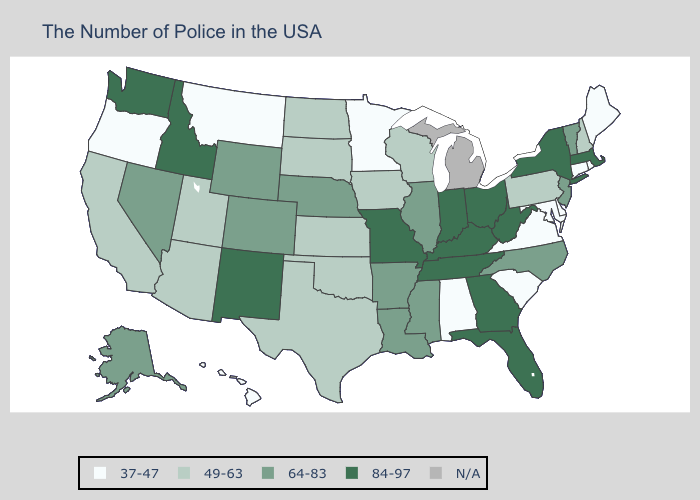Which states have the lowest value in the USA?
Keep it brief. Maine, Rhode Island, Connecticut, Delaware, Maryland, Virginia, South Carolina, Alabama, Minnesota, Montana, Oregon, Hawaii. Does Illinois have the lowest value in the USA?
Keep it brief. No. What is the lowest value in the South?
Answer briefly. 37-47. What is the lowest value in the USA?
Be succinct. 37-47. What is the lowest value in the MidWest?
Answer briefly. 37-47. Which states hav the highest value in the Northeast?
Answer briefly. Massachusetts, New York. Name the states that have a value in the range 37-47?
Write a very short answer. Maine, Rhode Island, Connecticut, Delaware, Maryland, Virginia, South Carolina, Alabama, Minnesota, Montana, Oregon, Hawaii. What is the value of Indiana?
Concise answer only. 84-97. Among the states that border Mississippi , which have the highest value?
Give a very brief answer. Tennessee. Does the first symbol in the legend represent the smallest category?
Answer briefly. Yes. What is the lowest value in the USA?
Write a very short answer. 37-47. Does Vermont have the lowest value in the Northeast?
Be succinct. No. Name the states that have a value in the range 84-97?
Keep it brief. Massachusetts, New York, West Virginia, Ohio, Florida, Georgia, Kentucky, Indiana, Tennessee, Missouri, New Mexico, Idaho, Washington. 